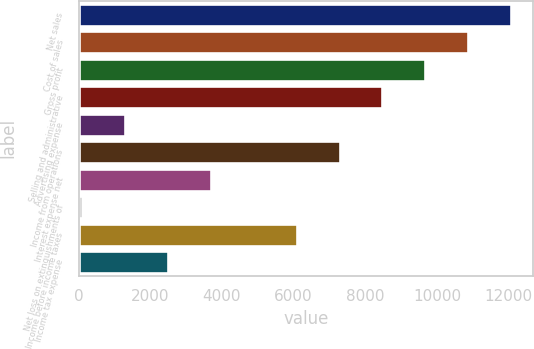Convert chart. <chart><loc_0><loc_0><loc_500><loc_500><bar_chart><fcel>Net sales<fcel>Cost of sales<fcel>Gross profit<fcel>Selling and administrative<fcel>Advertising expense<fcel>Income from operations<fcel>Interest expense net<fcel>Net loss on extinguishments of<fcel>Income before income taxes<fcel>Income tax expense<nl><fcel>12074.5<fcel>10876.1<fcel>9677.74<fcel>8479.36<fcel>1289.08<fcel>7280.98<fcel>3685.84<fcel>90.7<fcel>6082.6<fcel>2487.46<nl></chart> 